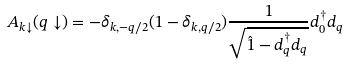Convert formula to latex. <formula><loc_0><loc_0><loc_500><loc_500>A _ { { k } \downarrow } ( { q } \downarrow ) = - \delta _ { { k } , - { q } / 2 } ( 1 - \delta _ { { k } , { q } / 2 } ) \frac { 1 } { \sqrt { { \hat { 1 } } - d ^ { \dagger } _ { q } d _ { q } } } d ^ { \dagger } _ { 0 } d _ { q }</formula> 